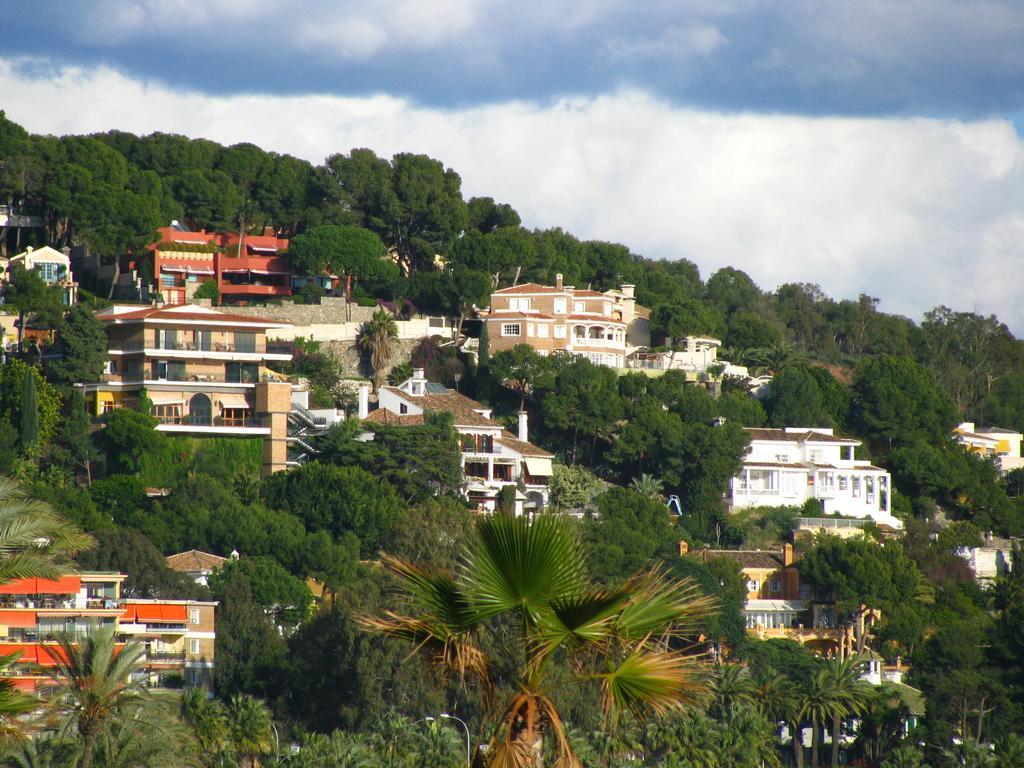How would you summarize this image in a sentence or two? In the image there are a lot of trees and in between the trees there are buildings and houses. 